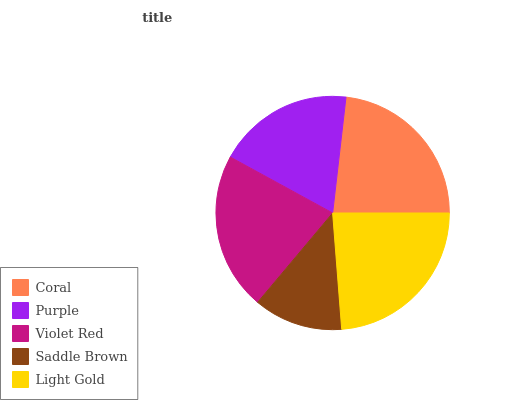Is Saddle Brown the minimum?
Answer yes or no. Yes. Is Light Gold the maximum?
Answer yes or no. Yes. Is Purple the minimum?
Answer yes or no. No. Is Purple the maximum?
Answer yes or no. No. Is Coral greater than Purple?
Answer yes or no. Yes. Is Purple less than Coral?
Answer yes or no. Yes. Is Purple greater than Coral?
Answer yes or no. No. Is Coral less than Purple?
Answer yes or no. No. Is Violet Red the high median?
Answer yes or no. Yes. Is Violet Red the low median?
Answer yes or no. Yes. Is Saddle Brown the high median?
Answer yes or no. No. Is Purple the low median?
Answer yes or no. No. 